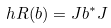<formula> <loc_0><loc_0><loc_500><loc_500>\ h R ( b ) = J b ^ { * } J</formula> 